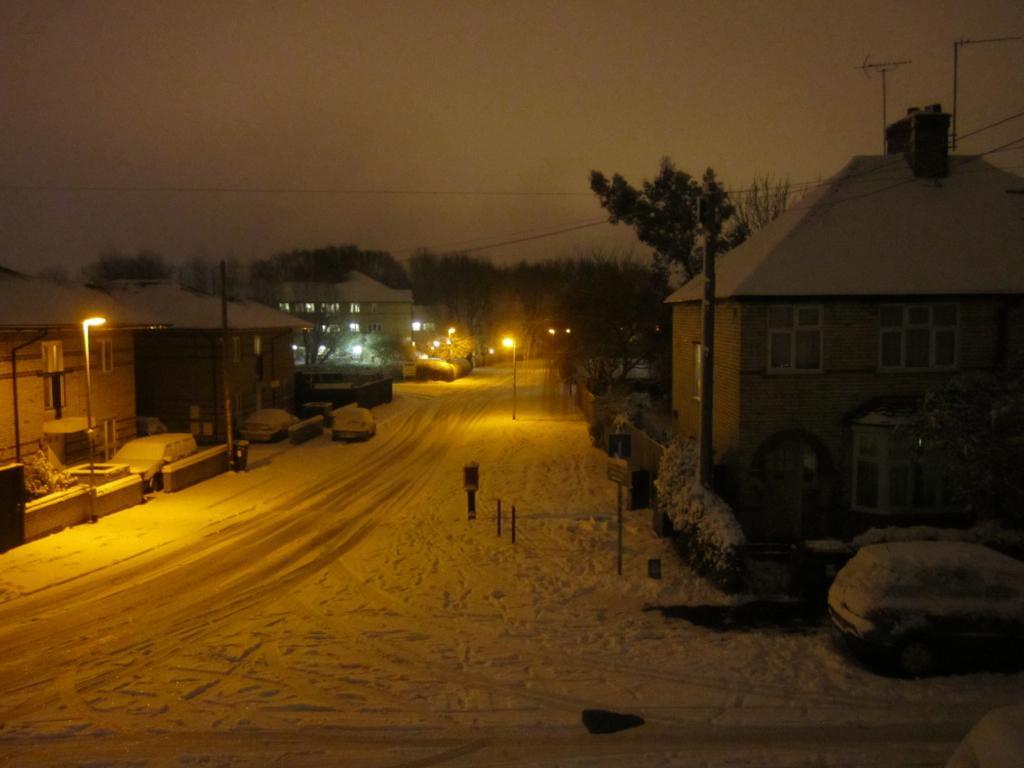Please provide a concise description of this image. In this image I can see the road, some snow on the road, few poles, few lights, a car, few buildings and few trees on both sides of the road. In the background I can see the sky. 